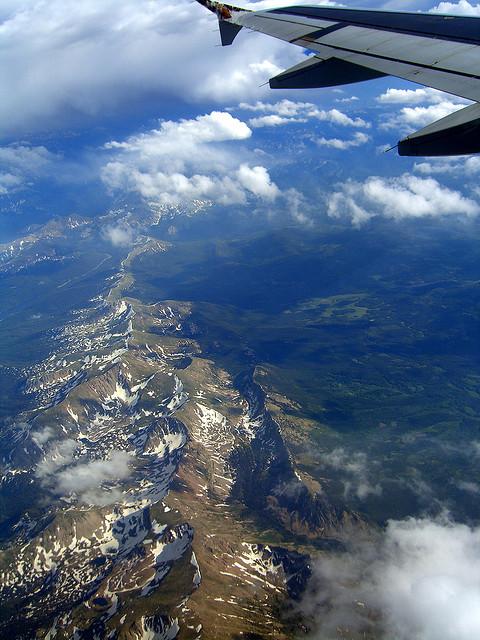Are there clouds in the sky?
Be succinct. Yes. Is the photo clear?
Quick response, please. Yes. Is the plane over water?
Be succinct. No. What kind of landscape is seen here from the plane window?
Write a very short answer. Mountains. Can you see the whole plane?
Be succinct. No. What size is the jet engine?
Short answer required. Big. What is the dominant color in this photo?
Quick response, please. Blue. What is on the mountain?
Concise answer only. Snow. 